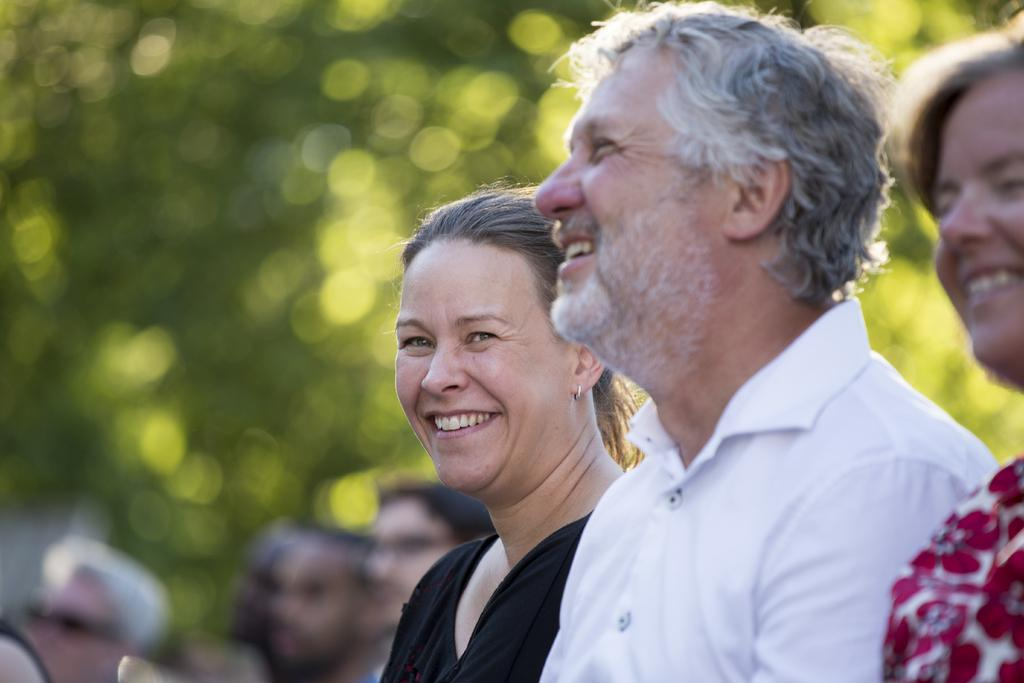How many people are present in the image? There are three people in the image. What is the facial expression of the people in the image? The people are smiling. Can you describe the background of the image? The background is blurry and green. Are there any other people visible in the image besides the main three? Yes, there are people visible in the background. What is the income of the people in the image? There is no information about the income of the people in the image. What story are the people in the image telling each other? There is no indication of a story being told in the image. 